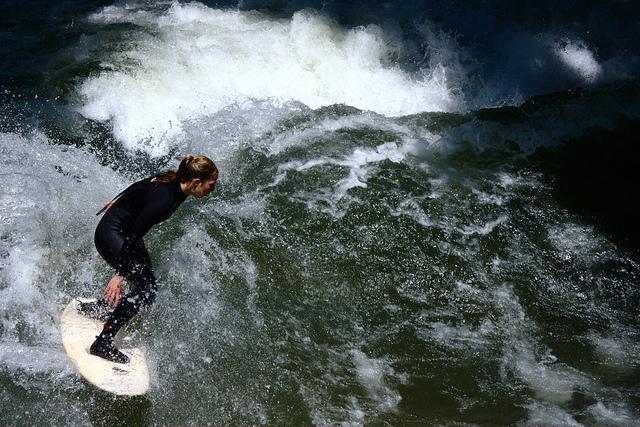Is the water calm?
Be succinct. No. Will a shark jump out and bite the surgery?
Answer briefly. No. Is the man barefoot?
Keep it brief. No. Is the surfer a woman?
Be succinct. Yes. What color is surfboard?
Be succinct. White. 